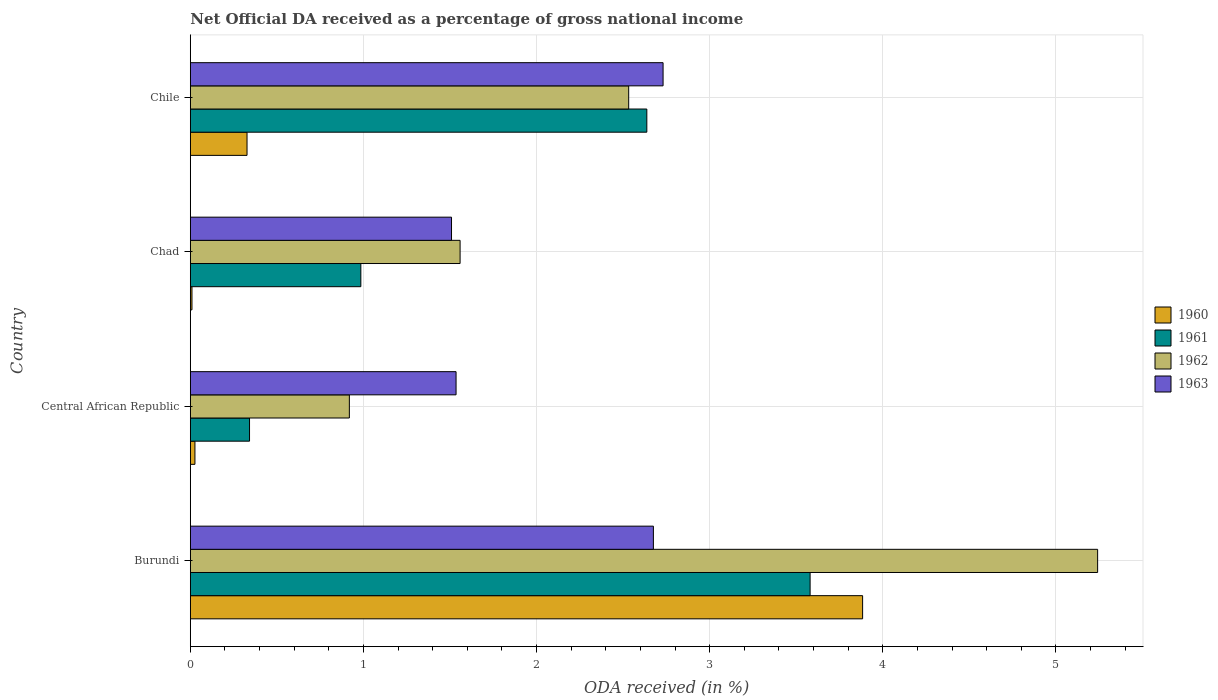How many bars are there on the 1st tick from the bottom?
Your response must be concise. 4. What is the label of the 3rd group of bars from the top?
Your answer should be compact. Central African Republic. What is the net official DA received in 1961 in Chad?
Make the answer very short. 0.99. Across all countries, what is the maximum net official DA received in 1960?
Offer a very short reply. 3.88. Across all countries, what is the minimum net official DA received in 1962?
Provide a short and direct response. 0.92. In which country was the net official DA received in 1960 maximum?
Offer a terse response. Burundi. In which country was the net official DA received in 1962 minimum?
Offer a very short reply. Central African Republic. What is the total net official DA received in 1961 in the graph?
Your answer should be compact. 7.54. What is the difference between the net official DA received in 1963 in Burundi and that in Central African Republic?
Offer a very short reply. 1.14. What is the difference between the net official DA received in 1961 in Chad and the net official DA received in 1962 in Burundi?
Your answer should be very brief. -4.26. What is the average net official DA received in 1963 per country?
Make the answer very short. 2.11. What is the difference between the net official DA received in 1961 and net official DA received in 1963 in Chile?
Your answer should be very brief. -0.09. In how many countries, is the net official DA received in 1962 greater than 2.4 %?
Make the answer very short. 2. What is the ratio of the net official DA received in 1962 in Central African Republic to that in Chad?
Offer a very short reply. 0.59. Is the net official DA received in 1960 in Burundi less than that in Chile?
Make the answer very short. No. What is the difference between the highest and the second highest net official DA received in 1961?
Provide a succinct answer. 0.94. What is the difference between the highest and the lowest net official DA received in 1963?
Provide a succinct answer. 1.22. In how many countries, is the net official DA received in 1962 greater than the average net official DA received in 1962 taken over all countries?
Provide a short and direct response. 1. Is the sum of the net official DA received in 1961 in Chad and Chile greater than the maximum net official DA received in 1963 across all countries?
Make the answer very short. Yes. What does the 1st bar from the top in Chad represents?
Provide a succinct answer. 1963. What does the 4th bar from the bottom in Chad represents?
Make the answer very short. 1963. Are all the bars in the graph horizontal?
Ensure brevity in your answer.  Yes. How many countries are there in the graph?
Keep it short and to the point. 4. Are the values on the major ticks of X-axis written in scientific E-notation?
Ensure brevity in your answer.  No. How many legend labels are there?
Provide a succinct answer. 4. What is the title of the graph?
Your response must be concise. Net Official DA received as a percentage of gross national income. What is the label or title of the X-axis?
Offer a very short reply. ODA received (in %). What is the label or title of the Y-axis?
Offer a very short reply. Country. What is the ODA received (in %) in 1960 in Burundi?
Make the answer very short. 3.88. What is the ODA received (in %) in 1961 in Burundi?
Offer a terse response. 3.58. What is the ODA received (in %) in 1962 in Burundi?
Provide a succinct answer. 5.24. What is the ODA received (in %) of 1963 in Burundi?
Ensure brevity in your answer.  2.68. What is the ODA received (in %) in 1960 in Central African Republic?
Offer a very short reply. 0.03. What is the ODA received (in %) of 1961 in Central African Republic?
Make the answer very short. 0.34. What is the ODA received (in %) of 1962 in Central African Republic?
Keep it short and to the point. 0.92. What is the ODA received (in %) of 1963 in Central African Republic?
Your response must be concise. 1.54. What is the ODA received (in %) of 1960 in Chad?
Offer a very short reply. 0.01. What is the ODA received (in %) of 1961 in Chad?
Keep it short and to the point. 0.99. What is the ODA received (in %) in 1962 in Chad?
Provide a succinct answer. 1.56. What is the ODA received (in %) in 1963 in Chad?
Make the answer very short. 1.51. What is the ODA received (in %) in 1960 in Chile?
Offer a very short reply. 0.33. What is the ODA received (in %) in 1961 in Chile?
Your answer should be compact. 2.64. What is the ODA received (in %) of 1962 in Chile?
Ensure brevity in your answer.  2.53. What is the ODA received (in %) of 1963 in Chile?
Your answer should be compact. 2.73. Across all countries, what is the maximum ODA received (in %) of 1960?
Give a very brief answer. 3.88. Across all countries, what is the maximum ODA received (in %) in 1961?
Keep it short and to the point. 3.58. Across all countries, what is the maximum ODA received (in %) of 1962?
Your answer should be compact. 5.24. Across all countries, what is the maximum ODA received (in %) in 1963?
Keep it short and to the point. 2.73. Across all countries, what is the minimum ODA received (in %) in 1960?
Offer a very short reply. 0.01. Across all countries, what is the minimum ODA received (in %) of 1961?
Provide a succinct answer. 0.34. Across all countries, what is the minimum ODA received (in %) of 1962?
Provide a short and direct response. 0.92. Across all countries, what is the minimum ODA received (in %) of 1963?
Your answer should be very brief. 1.51. What is the total ODA received (in %) of 1960 in the graph?
Offer a terse response. 4.25. What is the total ODA received (in %) in 1961 in the graph?
Keep it short and to the point. 7.54. What is the total ODA received (in %) of 1962 in the graph?
Make the answer very short. 10.25. What is the total ODA received (in %) of 1963 in the graph?
Provide a succinct answer. 8.45. What is the difference between the ODA received (in %) of 1960 in Burundi and that in Central African Republic?
Keep it short and to the point. 3.86. What is the difference between the ODA received (in %) of 1961 in Burundi and that in Central African Republic?
Your answer should be very brief. 3.24. What is the difference between the ODA received (in %) in 1962 in Burundi and that in Central African Republic?
Ensure brevity in your answer.  4.32. What is the difference between the ODA received (in %) in 1963 in Burundi and that in Central African Republic?
Your answer should be very brief. 1.14. What is the difference between the ODA received (in %) of 1960 in Burundi and that in Chad?
Provide a short and direct response. 3.87. What is the difference between the ODA received (in %) in 1961 in Burundi and that in Chad?
Give a very brief answer. 2.6. What is the difference between the ODA received (in %) of 1962 in Burundi and that in Chad?
Offer a very short reply. 3.68. What is the difference between the ODA received (in %) of 1963 in Burundi and that in Chad?
Give a very brief answer. 1.17. What is the difference between the ODA received (in %) of 1960 in Burundi and that in Chile?
Keep it short and to the point. 3.56. What is the difference between the ODA received (in %) in 1961 in Burundi and that in Chile?
Provide a short and direct response. 0.94. What is the difference between the ODA received (in %) of 1962 in Burundi and that in Chile?
Provide a succinct answer. 2.71. What is the difference between the ODA received (in %) of 1963 in Burundi and that in Chile?
Give a very brief answer. -0.06. What is the difference between the ODA received (in %) of 1960 in Central African Republic and that in Chad?
Provide a succinct answer. 0.02. What is the difference between the ODA received (in %) of 1961 in Central African Republic and that in Chad?
Your answer should be very brief. -0.64. What is the difference between the ODA received (in %) in 1962 in Central African Republic and that in Chad?
Provide a succinct answer. -0.64. What is the difference between the ODA received (in %) in 1963 in Central African Republic and that in Chad?
Your response must be concise. 0.03. What is the difference between the ODA received (in %) of 1960 in Central African Republic and that in Chile?
Provide a short and direct response. -0.3. What is the difference between the ODA received (in %) of 1961 in Central African Republic and that in Chile?
Make the answer very short. -2.29. What is the difference between the ODA received (in %) in 1962 in Central African Republic and that in Chile?
Provide a short and direct response. -1.61. What is the difference between the ODA received (in %) of 1963 in Central African Republic and that in Chile?
Your answer should be very brief. -1.2. What is the difference between the ODA received (in %) of 1960 in Chad and that in Chile?
Provide a succinct answer. -0.32. What is the difference between the ODA received (in %) of 1961 in Chad and that in Chile?
Offer a terse response. -1.65. What is the difference between the ODA received (in %) in 1962 in Chad and that in Chile?
Offer a terse response. -0.97. What is the difference between the ODA received (in %) of 1963 in Chad and that in Chile?
Make the answer very short. -1.22. What is the difference between the ODA received (in %) in 1960 in Burundi and the ODA received (in %) in 1961 in Central African Republic?
Give a very brief answer. 3.54. What is the difference between the ODA received (in %) in 1960 in Burundi and the ODA received (in %) in 1962 in Central African Republic?
Provide a short and direct response. 2.96. What is the difference between the ODA received (in %) of 1960 in Burundi and the ODA received (in %) of 1963 in Central African Republic?
Offer a very short reply. 2.35. What is the difference between the ODA received (in %) in 1961 in Burundi and the ODA received (in %) in 1962 in Central African Republic?
Give a very brief answer. 2.66. What is the difference between the ODA received (in %) of 1961 in Burundi and the ODA received (in %) of 1963 in Central African Republic?
Provide a succinct answer. 2.05. What is the difference between the ODA received (in %) of 1962 in Burundi and the ODA received (in %) of 1963 in Central African Republic?
Offer a very short reply. 3.71. What is the difference between the ODA received (in %) in 1960 in Burundi and the ODA received (in %) in 1961 in Chad?
Keep it short and to the point. 2.9. What is the difference between the ODA received (in %) of 1960 in Burundi and the ODA received (in %) of 1962 in Chad?
Provide a succinct answer. 2.33. What is the difference between the ODA received (in %) in 1960 in Burundi and the ODA received (in %) in 1963 in Chad?
Provide a short and direct response. 2.37. What is the difference between the ODA received (in %) of 1961 in Burundi and the ODA received (in %) of 1962 in Chad?
Give a very brief answer. 2.02. What is the difference between the ODA received (in %) of 1961 in Burundi and the ODA received (in %) of 1963 in Chad?
Your answer should be very brief. 2.07. What is the difference between the ODA received (in %) of 1962 in Burundi and the ODA received (in %) of 1963 in Chad?
Offer a terse response. 3.73. What is the difference between the ODA received (in %) in 1960 in Burundi and the ODA received (in %) in 1961 in Chile?
Provide a short and direct response. 1.25. What is the difference between the ODA received (in %) in 1960 in Burundi and the ODA received (in %) in 1962 in Chile?
Give a very brief answer. 1.35. What is the difference between the ODA received (in %) in 1960 in Burundi and the ODA received (in %) in 1963 in Chile?
Provide a succinct answer. 1.15. What is the difference between the ODA received (in %) in 1961 in Burundi and the ODA received (in %) in 1962 in Chile?
Give a very brief answer. 1.05. What is the difference between the ODA received (in %) of 1961 in Burundi and the ODA received (in %) of 1963 in Chile?
Your answer should be very brief. 0.85. What is the difference between the ODA received (in %) of 1962 in Burundi and the ODA received (in %) of 1963 in Chile?
Your answer should be very brief. 2.51. What is the difference between the ODA received (in %) of 1960 in Central African Republic and the ODA received (in %) of 1961 in Chad?
Your response must be concise. -0.96. What is the difference between the ODA received (in %) of 1960 in Central African Republic and the ODA received (in %) of 1962 in Chad?
Provide a succinct answer. -1.53. What is the difference between the ODA received (in %) in 1960 in Central African Republic and the ODA received (in %) in 1963 in Chad?
Keep it short and to the point. -1.48. What is the difference between the ODA received (in %) in 1961 in Central African Republic and the ODA received (in %) in 1962 in Chad?
Provide a short and direct response. -1.22. What is the difference between the ODA received (in %) of 1961 in Central African Republic and the ODA received (in %) of 1963 in Chad?
Keep it short and to the point. -1.17. What is the difference between the ODA received (in %) in 1962 in Central African Republic and the ODA received (in %) in 1963 in Chad?
Offer a very short reply. -0.59. What is the difference between the ODA received (in %) of 1960 in Central African Republic and the ODA received (in %) of 1961 in Chile?
Your response must be concise. -2.61. What is the difference between the ODA received (in %) of 1960 in Central African Republic and the ODA received (in %) of 1962 in Chile?
Offer a very short reply. -2.51. What is the difference between the ODA received (in %) of 1960 in Central African Republic and the ODA received (in %) of 1963 in Chile?
Ensure brevity in your answer.  -2.7. What is the difference between the ODA received (in %) of 1961 in Central African Republic and the ODA received (in %) of 1962 in Chile?
Give a very brief answer. -2.19. What is the difference between the ODA received (in %) of 1961 in Central African Republic and the ODA received (in %) of 1963 in Chile?
Make the answer very short. -2.39. What is the difference between the ODA received (in %) of 1962 in Central African Republic and the ODA received (in %) of 1963 in Chile?
Provide a short and direct response. -1.81. What is the difference between the ODA received (in %) in 1960 in Chad and the ODA received (in %) in 1961 in Chile?
Give a very brief answer. -2.63. What is the difference between the ODA received (in %) of 1960 in Chad and the ODA received (in %) of 1962 in Chile?
Your answer should be compact. -2.52. What is the difference between the ODA received (in %) of 1960 in Chad and the ODA received (in %) of 1963 in Chile?
Your answer should be very brief. -2.72. What is the difference between the ODA received (in %) of 1961 in Chad and the ODA received (in %) of 1962 in Chile?
Your answer should be very brief. -1.55. What is the difference between the ODA received (in %) of 1961 in Chad and the ODA received (in %) of 1963 in Chile?
Provide a short and direct response. -1.75. What is the difference between the ODA received (in %) in 1962 in Chad and the ODA received (in %) in 1963 in Chile?
Offer a very short reply. -1.17. What is the average ODA received (in %) in 1960 per country?
Provide a succinct answer. 1.06. What is the average ODA received (in %) of 1961 per country?
Your answer should be compact. 1.89. What is the average ODA received (in %) in 1962 per country?
Offer a terse response. 2.56. What is the average ODA received (in %) in 1963 per country?
Make the answer very short. 2.11. What is the difference between the ODA received (in %) in 1960 and ODA received (in %) in 1961 in Burundi?
Keep it short and to the point. 0.3. What is the difference between the ODA received (in %) of 1960 and ODA received (in %) of 1962 in Burundi?
Offer a terse response. -1.36. What is the difference between the ODA received (in %) in 1960 and ODA received (in %) in 1963 in Burundi?
Your answer should be compact. 1.21. What is the difference between the ODA received (in %) in 1961 and ODA received (in %) in 1962 in Burundi?
Give a very brief answer. -1.66. What is the difference between the ODA received (in %) of 1961 and ODA received (in %) of 1963 in Burundi?
Keep it short and to the point. 0.91. What is the difference between the ODA received (in %) in 1962 and ODA received (in %) in 1963 in Burundi?
Ensure brevity in your answer.  2.57. What is the difference between the ODA received (in %) of 1960 and ODA received (in %) of 1961 in Central African Republic?
Offer a terse response. -0.32. What is the difference between the ODA received (in %) in 1960 and ODA received (in %) in 1962 in Central African Republic?
Ensure brevity in your answer.  -0.89. What is the difference between the ODA received (in %) of 1960 and ODA received (in %) of 1963 in Central African Republic?
Your answer should be very brief. -1.51. What is the difference between the ODA received (in %) of 1961 and ODA received (in %) of 1962 in Central African Republic?
Keep it short and to the point. -0.58. What is the difference between the ODA received (in %) in 1961 and ODA received (in %) in 1963 in Central African Republic?
Offer a very short reply. -1.19. What is the difference between the ODA received (in %) of 1962 and ODA received (in %) of 1963 in Central African Republic?
Offer a very short reply. -0.62. What is the difference between the ODA received (in %) in 1960 and ODA received (in %) in 1961 in Chad?
Provide a short and direct response. -0.98. What is the difference between the ODA received (in %) of 1960 and ODA received (in %) of 1962 in Chad?
Your answer should be very brief. -1.55. What is the difference between the ODA received (in %) in 1960 and ODA received (in %) in 1963 in Chad?
Offer a very short reply. -1.5. What is the difference between the ODA received (in %) of 1961 and ODA received (in %) of 1962 in Chad?
Provide a succinct answer. -0.57. What is the difference between the ODA received (in %) in 1961 and ODA received (in %) in 1963 in Chad?
Offer a terse response. -0.52. What is the difference between the ODA received (in %) in 1962 and ODA received (in %) in 1963 in Chad?
Make the answer very short. 0.05. What is the difference between the ODA received (in %) of 1960 and ODA received (in %) of 1961 in Chile?
Your answer should be compact. -2.31. What is the difference between the ODA received (in %) of 1960 and ODA received (in %) of 1962 in Chile?
Give a very brief answer. -2.2. What is the difference between the ODA received (in %) in 1960 and ODA received (in %) in 1963 in Chile?
Give a very brief answer. -2.4. What is the difference between the ODA received (in %) in 1961 and ODA received (in %) in 1962 in Chile?
Offer a terse response. 0.1. What is the difference between the ODA received (in %) of 1961 and ODA received (in %) of 1963 in Chile?
Your answer should be compact. -0.09. What is the difference between the ODA received (in %) of 1962 and ODA received (in %) of 1963 in Chile?
Your answer should be compact. -0.2. What is the ratio of the ODA received (in %) in 1960 in Burundi to that in Central African Republic?
Keep it short and to the point. 144.66. What is the ratio of the ODA received (in %) in 1961 in Burundi to that in Central African Republic?
Your response must be concise. 10.46. What is the ratio of the ODA received (in %) of 1962 in Burundi to that in Central African Republic?
Provide a short and direct response. 5.7. What is the ratio of the ODA received (in %) of 1963 in Burundi to that in Central African Republic?
Ensure brevity in your answer.  1.74. What is the ratio of the ODA received (in %) in 1960 in Burundi to that in Chad?
Offer a very short reply. 403.2. What is the ratio of the ODA received (in %) in 1961 in Burundi to that in Chad?
Your answer should be compact. 3.63. What is the ratio of the ODA received (in %) of 1962 in Burundi to that in Chad?
Your answer should be compact. 3.36. What is the ratio of the ODA received (in %) of 1963 in Burundi to that in Chad?
Make the answer very short. 1.77. What is the ratio of the ODA received (in %) in 1960 in Burundi to that in Chile?
Offer a very short reply. 11.85. What is the ratio of the ODA received (in %) in 1961 in Burundi to that in Chile?
Provide a succinct answer. 1.36. What is the ratio of the ODA received (in %) in 1962 in Burundi to that in Chile?
Your response must be concise. 2.07. What is the ratio of the ODA received (in %) of 1963 in Burundi to that in Chile?
Your answer should be very brief. 0.98. What is the ratio of the ODA received (in %) in 1960 in Central African Republic to that in Chad?
Your response must be concise. 2.79. What is the ratio of the ODA received (in %) of 1961 in Central African Republic to that in Chad?
Your answer should be compact. 0.35. What is the ratio of the ODA received (in %) of 1962 in Central African Republic to that in Chad?
Your response must be concise. 0.59. What is the ratio of the ODA received (in %) in 1963 in Central African Republic to that in Chad?
Give a very brief answer. 1.02. What is the ratio of the ODA received (in %) of 1960 in Central African Republic to that in Chile?
Your answer should be very brief. 0.08. What is the ratio of the ODA received (in %) in 1961 in Central African Republic to that in Chile?
Give a very brief answer. 0.13. What is the ratio of the ODA received (in %) of 1962 in Central African Republic to that in Chile?
Make the answer very short. 0.36. What is the ratio of the ODA received (in %) of 1963 in Central African Republic to that in Chile?
Ensure brevity in your answer.  0.56. What is the ratio of the ODA received (in %) of 1960 in Chad to that in Chile?
Ensure brevity in your answer.  0.03. What is the ratio of the ODA received (in %) in 1961 in Chad to that in Chile?
Give a very brief answer. 0.37. What is the ratio of the ODA received (in %) of 1962 in Chad to that in Chile?
Your answer should be compact. 0.62. What is the ratio of the ODA received (in %) of 1963 in Chad to that in Chile?
Ensure brevity in your answer.  0.55. What is the difference between the highest and the second highest ODA received (in %) of 1960?
Make the answer very short. 3.56. What is the difference between the highest and the second highest ODA received (in %) in 1961?
Offer a very short reply. 0.94. What is the difference between the highest and the second highest ODA received (in %) of 1962?
Provide a short and direct response. 2.71. What is the difference between the highest and the second highest ODA received (in %) in 1963?
Offer a very short reply. 0.06. What is the difference between the highest and the lowest ODA received (in %) in 1960?
Ensure brevity in your answer.  3.87. What is the difference between the highest and the lowest ODA received (in %) of 1961?
Your answer should be compact. 3.24. What is the difference between the highest and the lowest ODA received (in %) in 1962?
Your answer should be compact. 4.32. What is the difference between the highest and the lowest ODA received (in %) of 1963?
Provide a short and direct response. 1.22. 